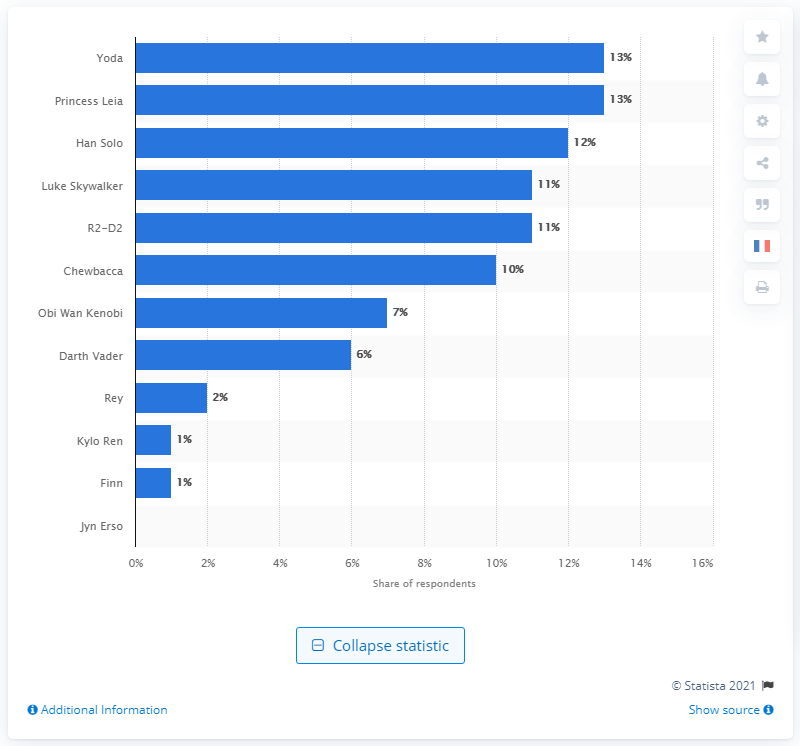List a handful of essential elements in this visual. The most popular Star Wars character was Princess Leia. 